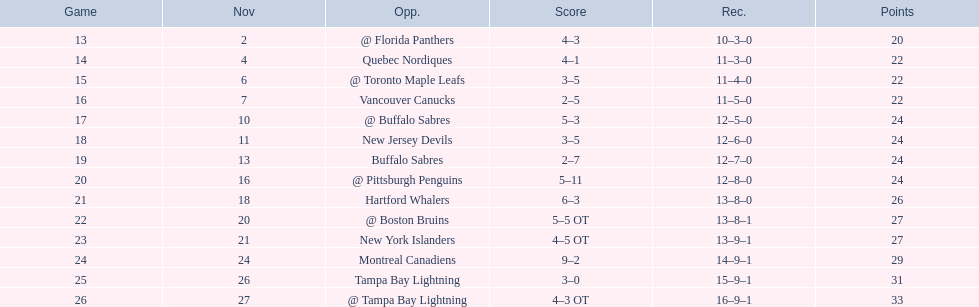What are the teams in the atlantic division? Quebec Nordiques, Vancouver Canucks, New Jersey Devils, Buffalo Sabres, Hartford Whalers, New York Islanders, Montreal Canadiens, Tampa Bay Lightning. Which of those scored fewer points than the philadelphia flyers? Tampa Bay Lightning. 